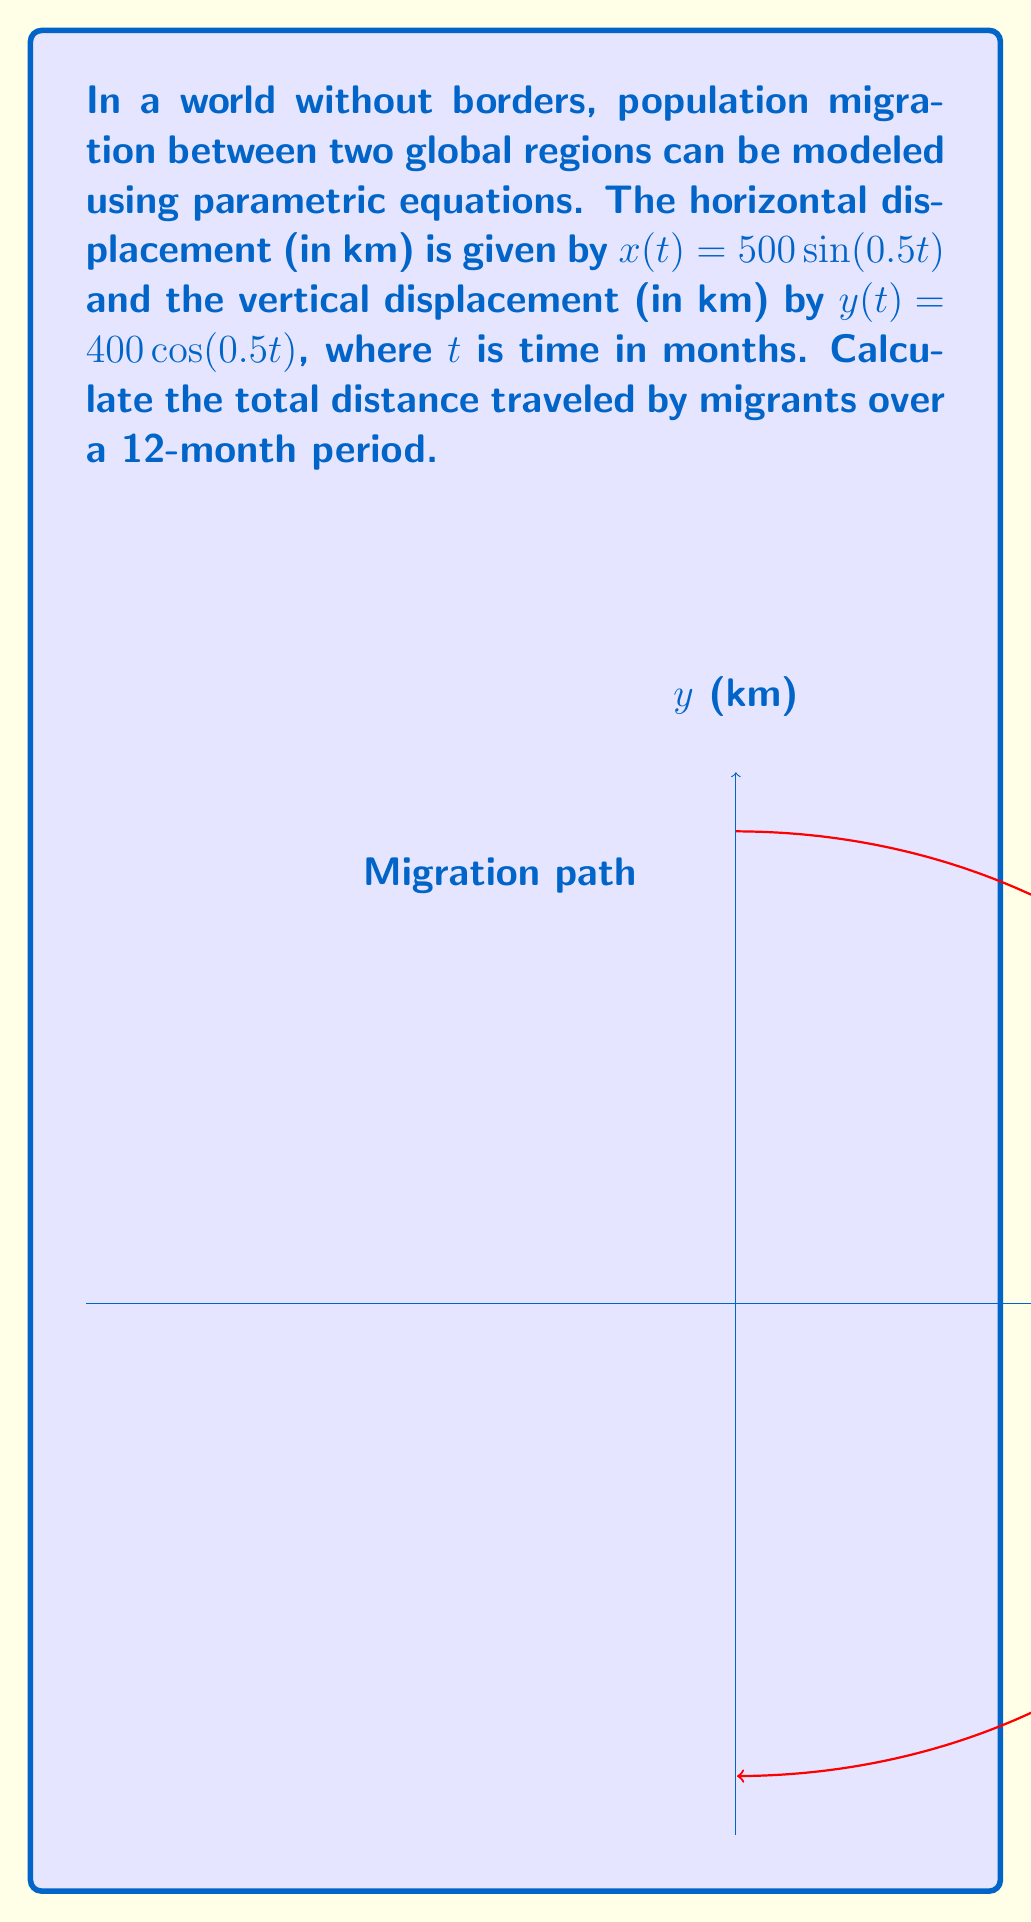Give your solution to this math problem. To solve this problem, we'll follow these steps:

1) The parametric equations are:
   $x(t) = 500\sin(0.5t)$
   $y(t) = 400\cos(0.5t)$

2) To find the distance traveled, we need to calculate the arc length over the given time period. The formula for arc length in parametric form is:

   $$L = \int_a^b \sqrt{\left(\frac{dx}{dt}\right)^2 + \left(\frac{dy}{dt}\right)^2} dt$$

3) First, let's find $\frac{dx}{dt}$ and $\frac{dy}{dt}$:
   $\frac{dx}{dt} = 250\cos(0.5t)$
   $\frac{dy}{dt} = -200\sin(0.5t)$

4) Now, let's substitute these into our arc length formula:

   $$L = \int_0^{12} \sqrt{(250\cos(0.5t))^2 + (-200\sin(0.5t))^2} dt$$

5) Simplify under the square root:

   $$L = \int_0^{12} \sqrt{62500\cos^2(0.5t) + 40000\sin^2(0.5t)} dt$$

6) Factor out the common term:

   $$L = \int_0^{12} \sqrt{62500(\cos^2(0.5t) + \frac{16}{25}\sin^2(0.5t))} dt$$

7) Simplify:

   $$L = 250\int_0^{12} \sqrt{\cos^2(0.5t) + \frac{16}{25}\sin^2(0.5t)} dt$$

8) This integral doesn't have an elementary antiderivative. We need to use numerical methods or a calculator to evaluate it.

9) Using a calculator or computer algebra system, we find:

   $$L \approx 2513.27 \text{ km}$$
Answer: 2513.27 km 